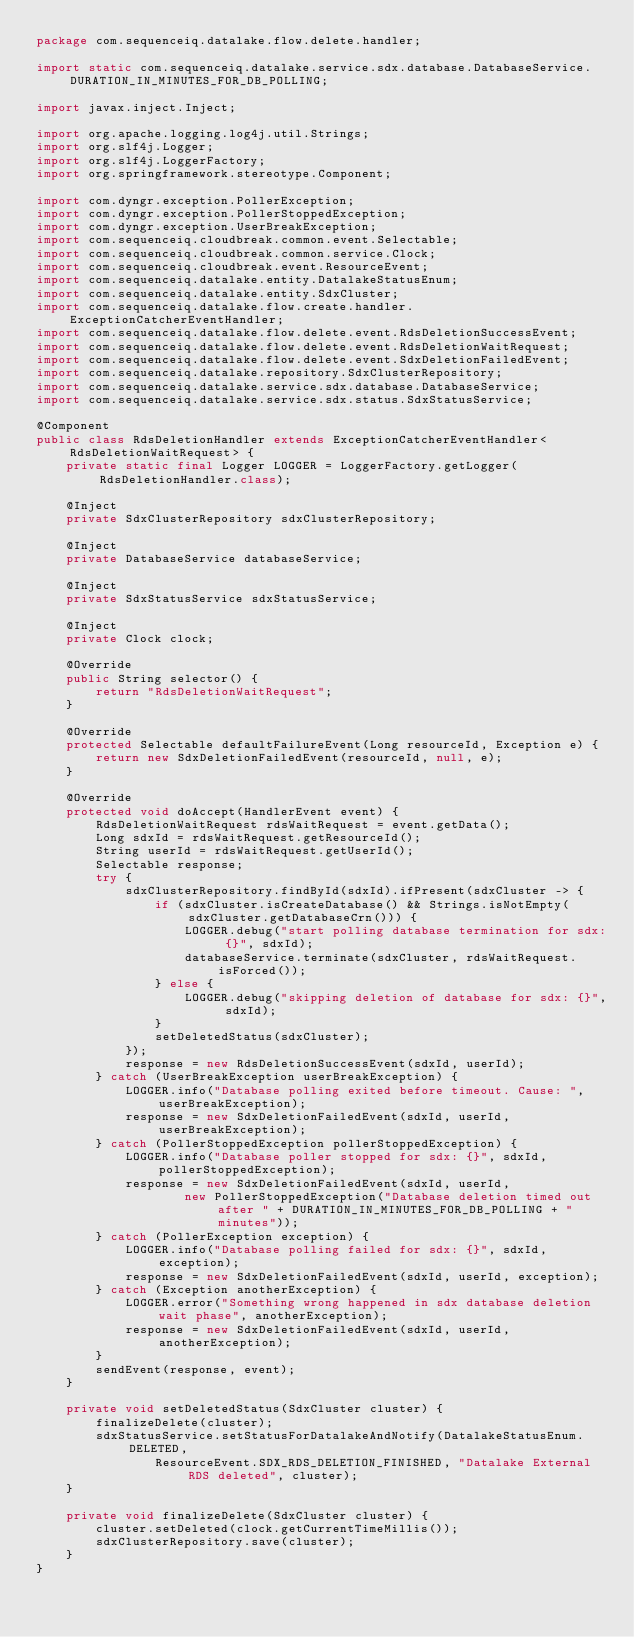Convert code to text. <code><loc_0><loc_0><loc_500><loc_500><_Java_>package com.sequenceiq.datalake.flow.delete.handler;

import static com.sequenceiq.datalake.service.sdx.database.DatabaseService.DURATION_IN_MINUTES_FOR_DB_POLLING;

import javax.inject.Inject;

import org.apache.logging.log4j.util.Strings;
import org.slf4j.Logger;
import org.slf4j.LoggerFactory;
import org.springframework.stereotype.Component;

import com.dyngr.exception.PollerException;
import com.dyngr.exception.PollerStoppedException;
import com.dyngr.exception.UserBreakException;
import com.sequenceiq.cloudbreak.common.event.Selectable;
import com.sequenceiq.cloudbreak.common.service.Clock;
import com.sequenceiq.cloudbreak.event.ResourceEvent;
import com.sequenceiq.datalake.entity.DatalakeStatusEnum;
import com.sequenceiq.datalake.entity.SdxCluster;
import com.sequenceiq.datalake.flow.create.handler.ExceptionCatcherEventHandler;
import com.sequenceiq.datalake.flow.delete.event.RdsDeletionSuccessEvent;
import com.sequenceiq.datalake.flow.delete.event.RdsDeletionWaitRequest;
import com.sequenceiq.datalake.flow.delete.event.SdxDeletionFailedEvent;
import com.sequenceiq.datalake.repository.SdxClusterRepository;
import com.sequenceiq.datalake.service.sdx.database.DatabaseService;
import com.sequenceiq.datalake.service.sdx.status.SdxStatusService;

@Component
public class RdsDeletionHandler extends ExceptionCatcherEventHandler<RdsDeletionWaitRequest> {
    private static final Logger LOGGER = LoggerFactory.getLogger(RdsDeletionHandler.class);

    @Inject
    private SdxClusterRepository sdxClusterRepository;

    @Inject
    private DatabaseService databaseService;

    @Inject
    private SdxStatusService sdxStatusService;

    @Inject
    private Clock clock;

    @Override
    public String selector() {
        return "RdsDeletionWaitRequest";
    }

    @Override
    protected Selectable defaultFailureEvent(Long resourceId, Exception e) {
        return new SdxDeletionFailedEvent(resourceId, null, e);
    }

    @Override
    protected void doAccept(HandlerEvent event) {
        RdsDeletionWaitRequest rdsWaitRequest = event.getData();
        Long sdxId = rdsWaitRequest.getResourceId();
        String userId = rdsWaitRequest.getUserId();
        Selectable response;
        try {
            sdxClusterRepository.findById(sdxId).ifPresent(sdxCluster -> {
                if (sdxCluster.isCreateDatabase() && Strings.isNotEmpty(sdxCluster.getDatabaseCrn())) {
                    LOGGER.debug("start polling database termination for sdx: {}", sdxId);
                    databaseService.terminate(sdxCluster, rdsWaitRequest.isForced());
                } else {
                    LOGGER.debug("skipping deletion of database for sdx: {}", sdxId);
                }
                setDeletedStatus(sdxCluster);
            });
            response = new RdsDeletionSuccessEvent(sdxId, userId);
        } catch (UserBreakException userBreakException) {
            LOGGER.info("Database polling exited before timeout. Cause: ", userBreakException);
            response = new SdxDeletionFailedEvent(sdxId, userId, userBreakException);
        } catch (PollerStoppedException pollerStoppedException) {
            LOGGER.info("Database poller stopped for sdx: {}", sdxId, pollerStoppedException);
            response = new SdxDeletionFailedEvent(sdxId, userId,
                    new PollerStoppedException("Database deletion timed out after " + DURATION_IN_MINUTES_FOR_DB_POLLING + " minutes"));
        } catch (PollerException exception) {
            LOGGER.info("Database polling failed for sdx: {}", sdxId, exception);
            response = new SdxDeletionFailedEvent(sdxId, userId, exception);
        } catch (Exception anotherException) {
            LOGGER.error("Something wrong happened in sdx database deletion wait phase", anotherException);
            response = new SdxDeletionFailedEvent(sdxId, userId, anotherException);
        }
        sendEvent(response, event);
    }

    private void setDeletedStatus(SdxCluster cluster) {
        finalizeDelete(cluster);
        sdxStatusService.setStatusForDatalakeAndNotify(DatalakeStatusEnum.DELETED,
                ResourceEvent.SDX_RDS_DELETION_FINISHED, "Datalake External RDS deleted", cluster);
    }

    private void finalizeDelete(SdxCluster cluster) {
        cluster.setDeleted(clock.getCurrentTimeMillis());
        sdxClusterRepository.save(cluster);
    }
}
</code> 